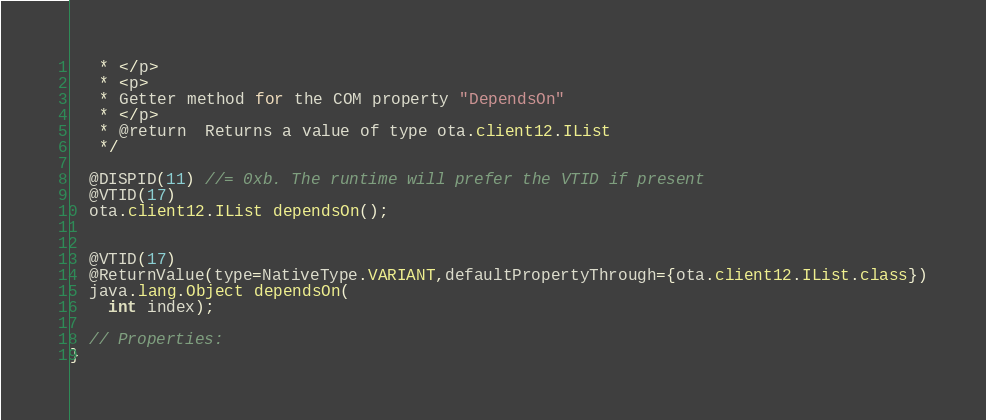<code> <loc_0><loc_0><loc_500><loc_500><_Java_>   * </p>
   * <p>
   * Getter method for the COM property "DependsOn"
   * </p>
   * @return  Returns a value of type ota.client12.IList
   */

  @DISPID(11) //= 0xb. The runtime will prefer the VTID if present
  @VTID(17)
  ota.client12.IList dependsOn();


  @VTID(17)
  @ReturnValue(type=NativeType.VARIANT,defaultPropertyThrough={ota.client12.IList.class})
  java.lang.Object dependsOn(
    int index);

  // Properties:
}
</code> 